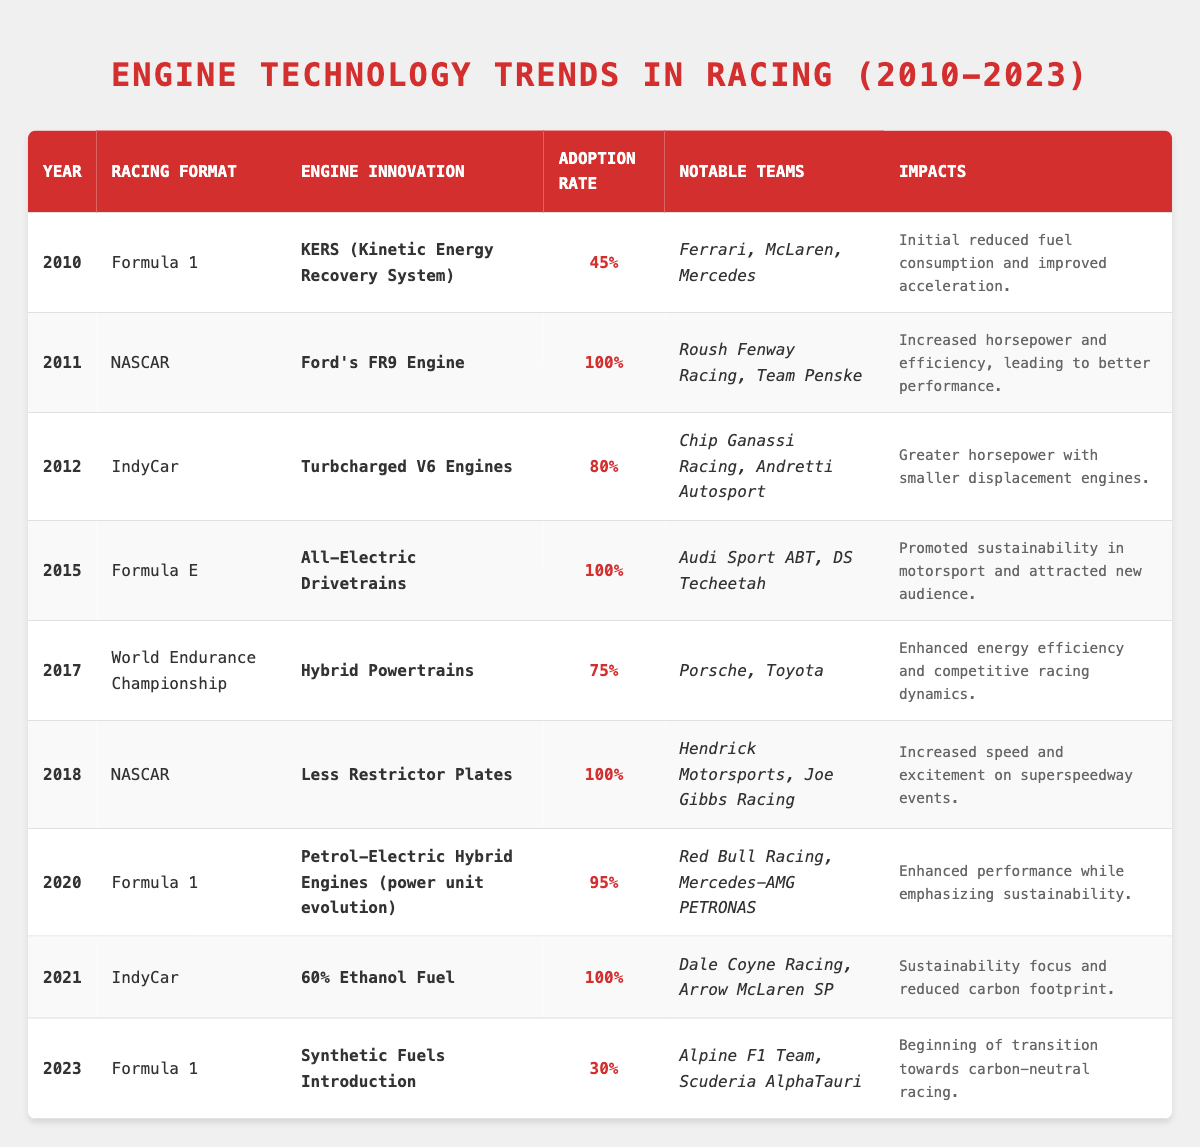What engine innovation was adopted in Formula 1 in 2010? According to the table, the engine innovation adopted in Formula 1 in 2010 was KERS (Kinetic Energy Recovery System).
Answer: KERS (Kinetic Energy Recovery System) Which racing formats had a 100% adoption rate for their engine innovations? The table shows that NASCAR in 2011 and 2018, as well as Formula E in 2015 and IndyCar in 2021, had a 100% adoption rate for their engine innovations.
Answer: NASCAR (2011, 2018), Formula E (2015), IndyCar (2021) What was the adoption rate of Petrol-Electric Hybrid Engines in Formula 1 in 2020? The adoption rate for Petrol-Electric Hybrid Engines in Formula 1 in 2020 was 95%, as indicated in the table.
Answer: 95% Which notable teams adopted Turbocharged V6 Engines in IndyCar in 2012? The notable teams that adopted Turbocharged V6 Engines in IndyCar in 2012 were Chip Ganassi Racing and Andretti Autosport, as shown in the table.
Answer: Chip Ganassi Racing, Andretti Autosport In which year did the use of Synthetic Fuels begin in Formula 1, and what was the adoption rate? The use of Synthetic Fuels began in Formula 1 in 2023 with an adoption rate of 30%, based on the information in the table.
Answer: 2023, 30% How many years from 2010 to 2023 had an engine innovation adoption rate of over 80%? By reviewing the table, the years with an adoption rate of over 80% are 2011 (100%), 2012 (80%), 2015 (100%), 2020 (95%), and 2021 (100%), totaling 5 years.
Answer: 5 Was there any engine innovation in the World Endurance Championship that had an adoption rate below 75%? The table indicates that the Hybrid Powertrains in World Endurance Championship had a 75% adoption rate, which is not below 75%. Therefore, the answer is no.
Answer: No What is the difference between the highest and lowest adoption rates listed in the table? The highest adoption rate listed in the table is 100% (multiple entries), and the lowest is 30% for Synthetic Fuels in 2023. The difference is 100% - 30% = 70%.
Answer: 70% Identify the racing format with the most recent adoption of a fuel type and its adoption rate. The most recent adoption of a fuel type listed in the table is Synthetic Fuels in Formula 1 in 2023, with an adoption rate of 30%.
Answer: Formula 1, 30% How did the introduction of All-Electric Drivetrains in Formula E impact sustainability? From the table, the introduction of All-Electric Drivetrains in Formula E promoted sustainability in motorsport and attracted a new audience.
Answer: Promoted sustainability and attracted a new audience Which two notable teams made a shift to 60% Ethanol Fuel in IndyCar in 2021? The notable teams that adopted 60% Ethanol Fuel in IndyCar in 2021 are Dale Coyne Racing and Arrow McLaren SP, as per the table.
Answer: Dale Coyne Racing, Arrow McLaren SP 